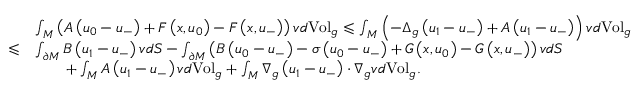Convert formula to latex. <formula><loc_0><loc_0><loc_500><loc_500>\begin{array} { r l } & { \int _ { M } \left ( A \left ( u _ { 0 } - u _ { - } \right ) + F \left ( x , u _ { 0 } \right ) - F \left ( x , u _ { - } \right ) \right ) v d V o l _ { g } \leqslant \int _ { M } \left ( - \Delta _ { g } \left ( u _ { 1 } - u _ { - } \right ) + A \left ( u _ { 1 } - u _ { - } \right ) \right ) v d V o l _ { g } } \\ { \leqslant } & { \int _ { \partial M } B \left ( u _ { 1 } - u _ { - } \right ) v d S - \int _ { \partial M } \left ( B \left ( u _ { 0 } - u _ { - } \right ) - \sigma \left ( u _ { 0 } - u _ { - } \right ) + G \left ( x , u _ { 0 } \right ) - G \left ( x , u _ { - } \right ) \right ) v d S } \\ & { \quad + \int _ { M } A \left ( u _ { 1 } - u _ { - } \right ) v d V o l _ { g } + \int _ { M } \nabla _ { g } \left ( u _ { 1 } - u _ { - } \right ) \cdot \nabla _ { g } v d V o l _ { g } . } \end{array}</formula> 